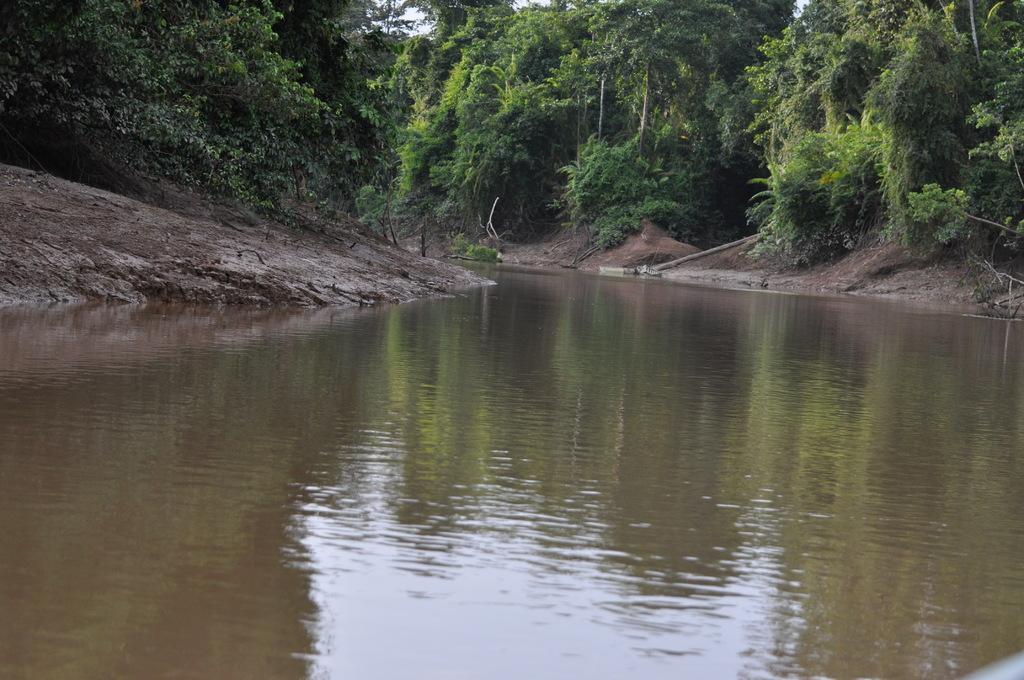In one or two sentences, can you explain what this image depicts? At the bottom of the image there is water. To both the sides of the image there are trees. 